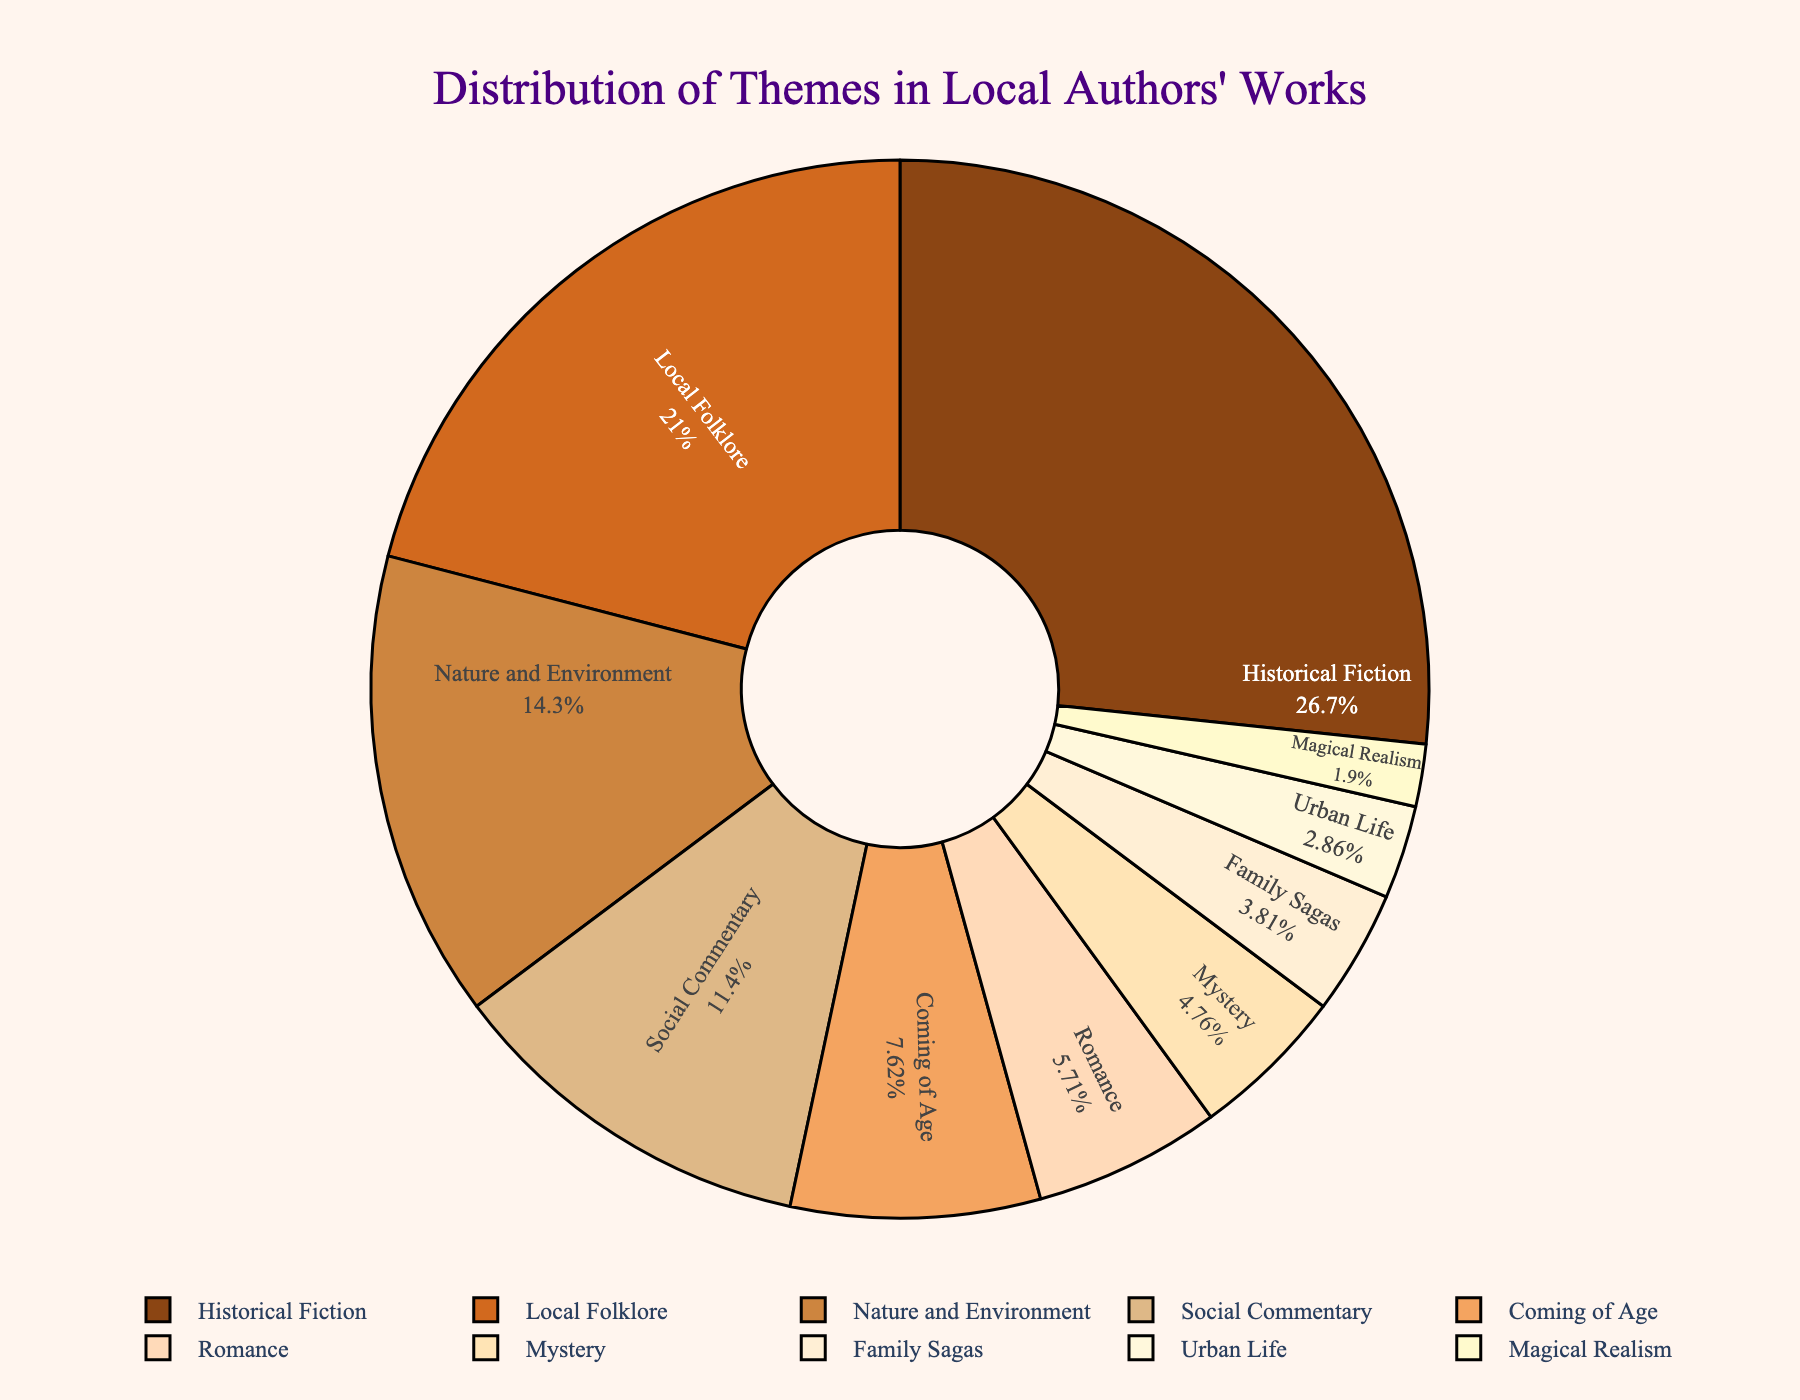What's the largest theme in the chart? The largest theme can be identified by looking at the section of the pie chart with the highest percentage. The "Historical Fiction" slice is the biggest and represents 28%.
Answer: Historical Fiction Which two themes combined account for more than 40% of the works? Identify the themes with the largest percentages and sum them until the total exceeds 40%. "Historical Fiction" (28%) and "Local Folklore" (22%) together total 50%, which is more than 40%.
Answer: Historical Fiction and Local Folklore How much more significant is Social Commentary compared to Urban Life? Social Commentary has a percentage of 12%, and Urban Life has 3%. The difference is calculated as 12% - 3% = 9%.
Answer: 9% What's the combined percentage of Nature and Environment and Coming of Age? Sum the percentages of "Nature and Environment" (15%) and "Coming of Age" (8%). 15% + 8% = 23%.
Answer: 23% Are there any themes that make up less than 5% of the total? If so, which ones? Identify the themes with percentages less than 5%. "Mystery" (5%), "Family Sagas" (4%), "Urban Life" (3%), and "Magical Realism" (2%) are all themes under 5%.
Answer: Mystery, Family Sagas, Urban Life, and Magical Realism How many themes are there in total on the pie chart? Count the number of unique segments or labels on the pie chart. There are 10 themes in total.
Answer: 10 How does the percentage of Romance compare to Coming of Age? Romance accounts for 6% and Coming of Age for 8%. Coming of Age is thus 2% higher than Romance.
Answer: Coming of Age is 2% higher If you combine the percentages of the smallest two themes, what is their total percentage? The smallest two themes are "Urban Life" (3%) and "Magical Realism" (2%). Their combined percentage is 3% + 2% = 5%.
Answer: 5% Which theme is represented by the lightest color in the pie chart? The lightest color in the custom color palette used is likely for the theme with the smallest percentage, which is "Magical Realism" with 2%.
Answer: Magical Realism 